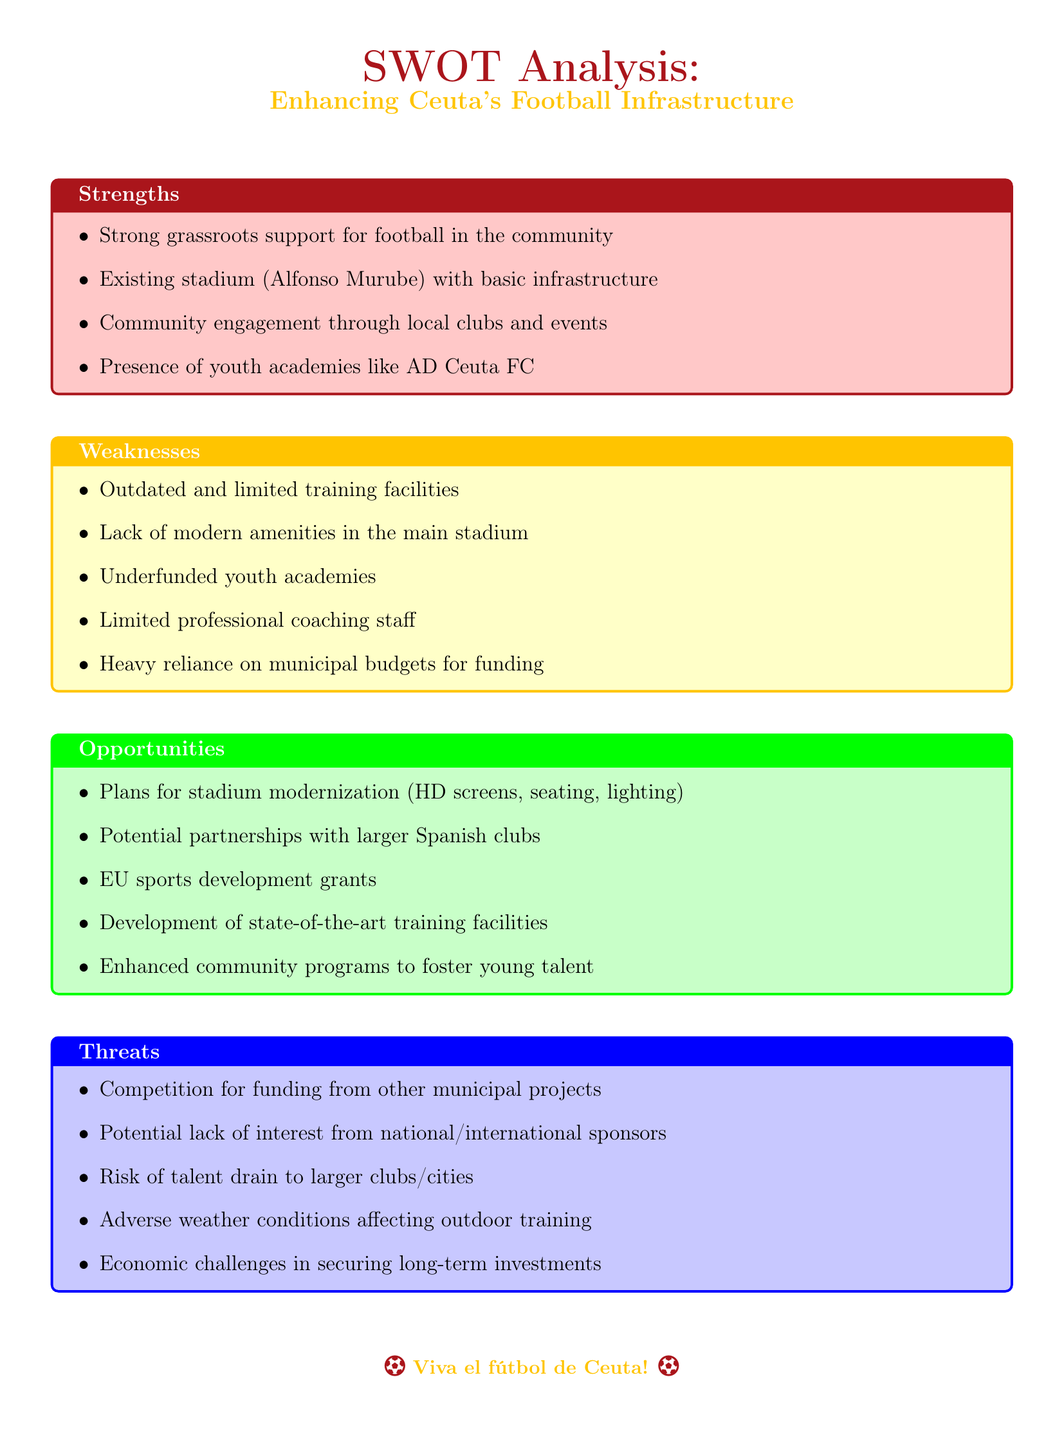What is the name of the existing stadium in Ceuta? The document lists the existing stadium as "Alfonso Murube."
Answer: Alfonso Murube What is one strength of Ceuta's football community? The analysis notes "Strong grassroots support for football in the community" as a strength.
Answer: Strong grassroots support What is one major weakness listed in the document? The weaknesses section identifies "Outdated and limited training facilities" as a specific weakness.
Answer: Outdated and limited training facilities What opportunity is mentioned for stadium modernization? The document states plans for "HD screens, seating, lighting" as part of the stadium modernization efforts.
Answer: HD screens, seating, lighting What is a potential threat to Ceuta's football infrastructure? Among potential threats, the document highlights "Risk of talent drain to larger clubs/cities."
Answer: Risk of talent drain How many youth academies are mentioned in the strengths section? The strengths section indicates the presence of "youth academies like AD Ceuta FC" which counts as one mention.
Answer: One Which groups could Ceuta's football collaborate with according to the opportunities? The document suggests "partnerships with larger Spanish clubs" as a collaboration opportunity.
Answer: Larger Spanish clubs What funding source is mentioned as a reliance in weaknesses? The weaknesses section indicates a "Heavy reliance on municipal budgets for funding."
Answer: Municipal budgets What community program is suggested to enhance talent? The opportunities section mentions "Enhanced community programs to foster young talent."
Answer: Enhanced community programs 